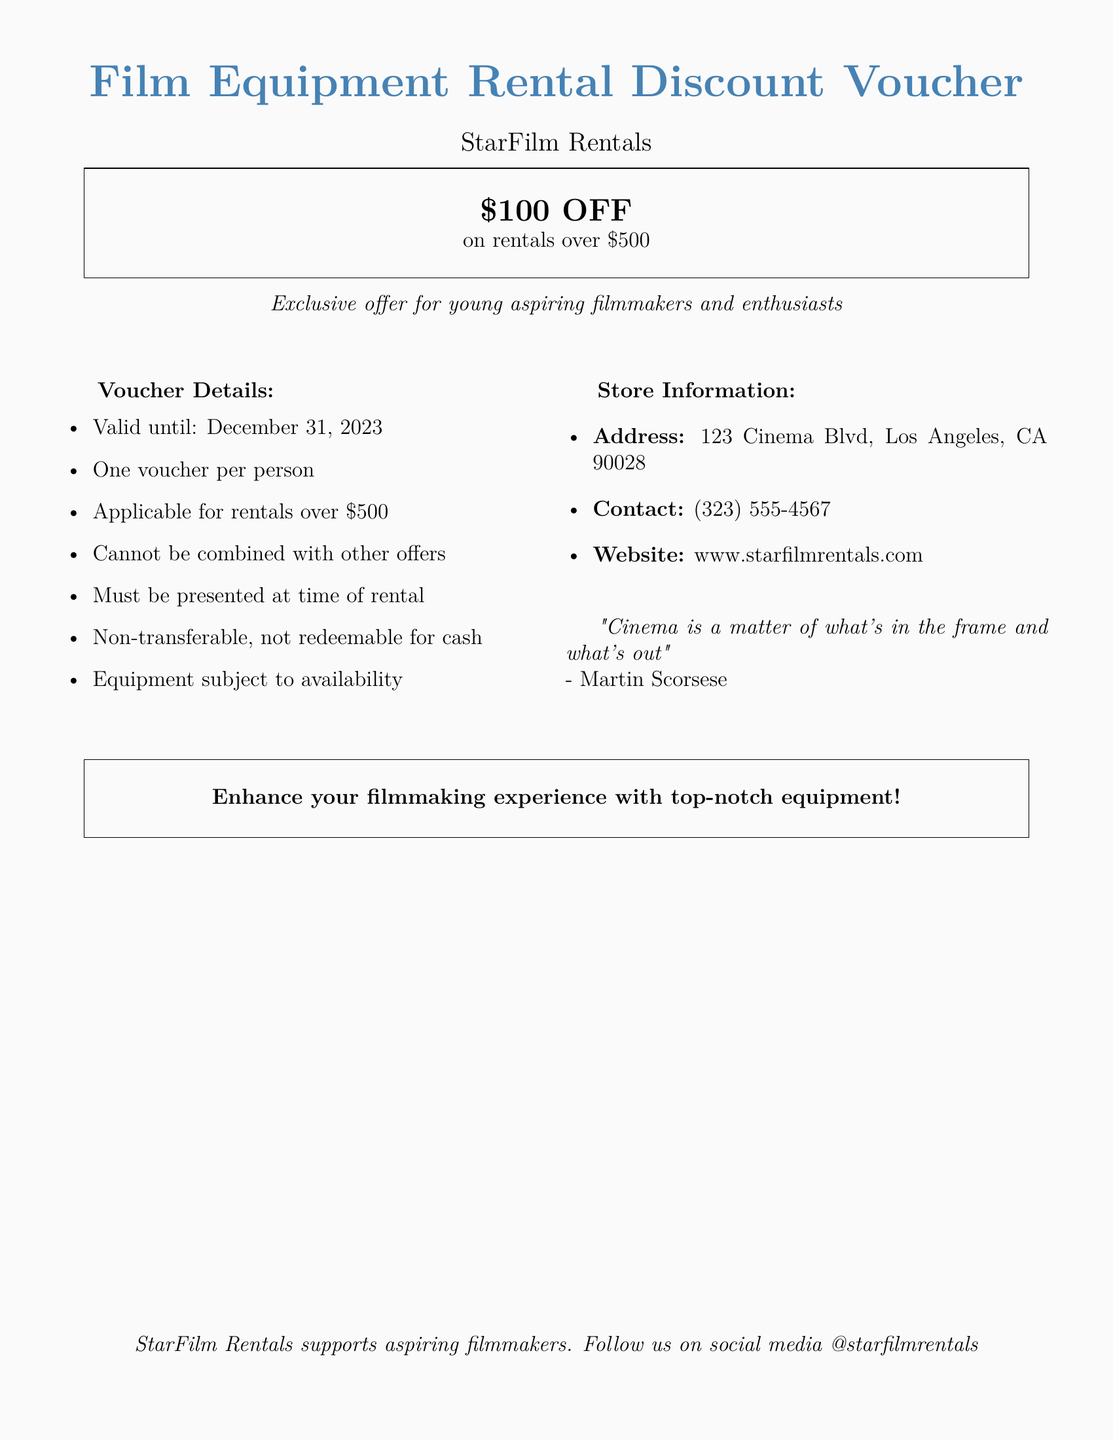what is the discount value offered? The discount value is mentioned as \$100 OFF on rentals over \$500.
Answer: \$100 what is the minimum rental amount to use the voucher? The document specifies that the voucher is applicable for rentals over \$500.
Answer: \$500 when does the voucher expire? The validity of the voucher is stated as until December 31, 2023.
Answer: December 31, 2023 how many vouchers can a person use? The document states that it is one voucher per person.
Answer: One is the voucher transferable? The details mention that the voucher is non-transferable.
Answer: No where is StarFilm Rentals located? The store address is provided in the document as 123 Cinema Blvd, Los Angeles, CA 90028.
Answer: 123 Cinema Blvd, Los Angeles, CA 90028 can the voucher be combined with other offers? The document states that the voucher cannot be combined with other offers.
Answer: No what must be done with the voucher at the time of rental? The document mentions that the voucher must be presented at the time of rental.
Answer: Presented at rental who is the target audience for this voucher? The document specifies that it is an exclusive offer for young aspiring filmmakers and enthusiasts.
Answer: Young aspiring filmmakers and enthusiasts 